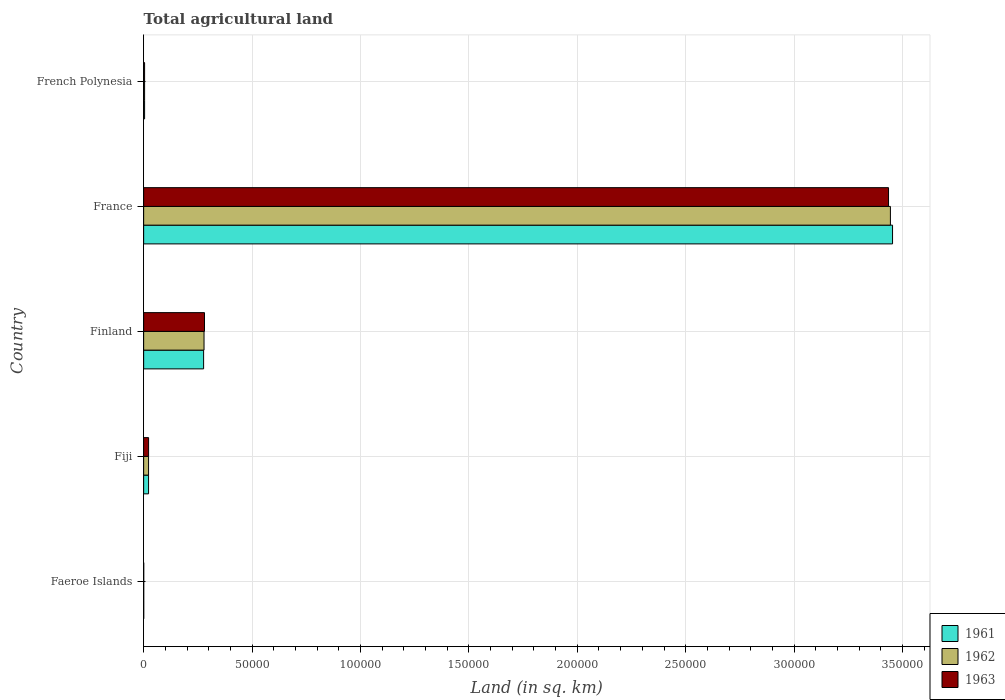How many different coloured bars are there?
Give a very brief answer. 3. Are the number of bars per tick equal to the number of legend labels?
Keep it short and to the point. Yes. Are the number of bars on each tick of the Y-axis equal?
Provide a succinct answer. Yes. How many bars are there on the 3rd tick from the bottom?
Offer a very short reply. 3. What is the label of the 3rd group of bars from the top?
Your answer should be compact. Finland. In how many cases, is the number of bars for a given country not equal to the number of legend labels?
Your response must be concise. 0. What is the total agricultural land in 1961 in French Polynesia?
Your answer should be very brief. 440. Across all countries, what is the maximum total agricultural land in 1963?
Your response must be concise. 3.44e+05. Across all countries, what is the minimum total agricultural land in 1962?
Ensure brevity in your answer.  30. In which country was the total agricultural land in 1962 maximum?
Provide a short and direct response. France. In which country was the total agricultural land in 1961 minimum?
Ensure brevity in your answer.  Faeroe Islands. What is the total total agricultural land in 1962 in the graph?
Keep it short and to the point. 3.75e+05. What is the difference between the total agricultural land in 1963 in Fiji and that in France?
Ensure brevity in your answer.  -3.41e+05. What is the difference between the total agricultural land in 1963 in French Polynesia and the total agricultural land in 1962 in France?
Your answer should be compact. -3.44e+05. What is the average total agricultural land in 1961 per country?
Ensure brevity in your answer.  7.52e+04. In how many countries, is the total agricultural land in 1963 greater than 220000 sq.km?
Give a very brief answer. 1. What is the ratio of the total agricultural land in 1962 in Faeroe Islands to that in France?
Ensure brevity in your answer.  8.710801393728223e-5. Is the difference between the total agricultural land in 1961 in France and French Polynesia greater than the difference between the total agricultural land in 1962 in France and French Polynesia?
Give a very brief answer. Yes. What is the difference between the highest and the second highest total agricultural land in 1963?
Your response must be concise. 3.15e+05. What is the difference between the highest and the lowest total agricultural land in 1962?
Offer a very short reply. 3.44e+05. In how many countries, is the total agricultural land in 1961 greater than the average total agricultural land in 1961 taken over all countries?
Provide a succinct answer. 1. What does the 2nd bar from the top in French Polynesia represents?
Provide a short and direct response. 1962. Is it the case that in every country, the sum of the total agricultural land in 1963 and total agricultural land in 1962 is greater than the total agricultural land in 1961?
Your response must be concise. Yes. How many bars are there?
Make the answer very short. 15. Are all the bars in the graph horizontal?
Your answer should be very brief. Yes. How many countries are there in the graph?
Make the answer very short. 5. What is the difference between two consecutive major ticks on the X-axis?
Your response must be concise. 5.00e+04. Does the graph contain any zero values?
Your answer should be very brief. No. Does the graph contain grids?
Make the answer very short. Yes. Where does the legend appear in the graph?
Offer a terse response. Bottom right. What is the title of the graph?
Offer a terse response. Total agricultural land. Does "1969" appear as one of the legend labels in the graph?
Your answer should be very brief. No. What is the label or title of the X-axis?
Offer a terse response. Land (in sq. km). What is the Land (in sq. km) of 1961 in Faeroe Islands?
Keep it short and to the point. 30. What is the Land (in sq. km) in 1962 in Faeroe Islands?
Your response must be concise. 30. What is the Land (in sq. km) of 1961 in Fiji?
Offer a terse response. 2270. What is the Land (in sq. km) of 1962 in Fiji?
Offer a terse response. 2270. What is the Land (in sq. km) in 1963 in Fiji?
Offer a terse response. 2280. What is the Land (in sq. km) of 1961 in Finland?
Keep it short and to the point. 2.77e+04. What is the Land (in sq. km) in 1962 in Finland?
Make the answer very short. 2.79e+04. What is the Land (in sq. km) in 1963 in Finland?
Your answer should be very brief. 2.81e+04. What is the Land (in sq. km) in 1961 in France?
Provide a short and direct response. 3.45e+05. What is the Land (in sq. km) of 1962 in France?
Give a very brief answer. 3.44e+05. What is the Land (in sq. km) of 1963 in France?
Provide a short and direct response. 3.44e+05. What is the Land (in sq. km) in 1961 in French Polynesia?
Provide a short and direct response. 440. What is the Land (in sq. km) in 1962 in French Polynesia?
Offer a terse response. 440. What is the Land (in sq. km) of 1963 in French Polynesia?
Provide a succinct answer. 440. Across all countries, what is the maximum Land (in sq. km) in 1961?
Give a very brief answer. 3.45e+05. Across all countries, what is the maximum Land (in sq. km) of 1962?
Offer a terse response. 3.44e+05. Across all countries, what is the maximum Land (in sq. km) in 1963?
Your answer should be compact. 3.44e+05. Across all countries, what is the minimum Land (in sq. km) of 1961?
Offer a terse response. 30. Across all countries, what is the minimum Land (in sq. km) of 1962?
Provide a succinct answer. 30. Across all countries, what is the minimum Land (in sq. km) of 1963?
Your answer should be compact. 30. What is the total Land (in sq. km) of 1961 in the graph?
Keep it short and to the point. 3.76e+05. What is the total Land (in sq. km) of 1962 in the graph?
Offer a terse response. 3.75e+05. What is the total Land (in sq. km) of 1963 in the graph?
Make the answer very short. 3.74e+05. What is the difference between the Land (in sq. km) of 1961 in Faeroe Islands and that in Fiji?
Your answer should be compact. -2240. What is the difference between the Land (in sq. km) in 1962 in Faeroe Islands and that in Fiji?
Your answer should be compact. -2240. What is the difference between the Land (in sq. km) of 1963 in Faeroe Islands and that in Fiji?
Give a very brief answer. -2250. What is the difference between the Land (in sq. km) in 1961 in Faeroe Islands and that in Finland?
Your response must be concise. -2.76e+04. What is the difference between the Land (in sq. km) of 1962 in Faeroe Islands and that in Finland?
Your response must be concise. -2.78e+04. What is the difference between the Land (in sq. km) in 1963 in Faeroe Islands and that in Finland?
Give a very brief answer. -2.80e+04. What is the difference between the Land (in sq. km) of 1961 in Faeroe Islands and that in France?
Your response must be concise. -3.45e+05. What is the difference between the Land (in sq. km) of 1962 in Faeroe Islands and that in France?
Keep it short and to the point. -3.44e+05. What is the difference between the Land (in sq. km) in 1963 in Faeroe Islands and that in France?
Your answer should be very brief. -3.44e+05. What is the difference between the Land (in sq. km) of 1961 in Faeroe Islands and that in French Polynesia?
Make the answer very short. -410. What is the difference between the Land (in sq. km) of 1962 in Faeroe Islands and that in French Polynesia?
Ensure brevity in your answer.  -410. What is the difference between the Land (in sq. km) of 1963 in Faeroe Islands and that in French Polynesia?
Your response must be concise. -410. What is the difference between the Land (in sq. km) of 1961 in Fiji and that in Finland?
Keep it short and to the point. -2.54e+04. What is the difference between the Land (in sq. km) of 1962 in Fiji and that in Finland?
Offer a very short reply. -2.56e+04. What is the difference between the Land (in sq. km) in 1963 in Fiji and that in Finland?
Provide a succinct answer. -2.58e+04. What is the difference between the Land (in sq. km) in 1961 in Fiji and that in France?
Provide a short and direct response. -3.43e+05. What is the difference between the Land (in sq. km) in 1962 in Fiji and that in France?
Your response must be concise. -3.42e+05. What is the difference between the Land (in sq. km) of 1963 in Fiji and that in France?
Offer a very short reply. -3.41e+05. What is the difference between the Land (in sq. km) in 1961 in Fiji and that in French Polynesia?
Make the answer very short. 1830. What is the difference between the Land (in sq. km) in 1962 in Fiji and that in French Polynesia?
Your answer should be compact. 1830. What is the difference between the Land (in sq. km) in 1963 in Fiji and that in French Polynesia?
Provide a short and direct response. 1840. What is the difference between the Land (in sq. km) in 1961 in Finland and that in France?
Offer a very short reply. -3.18e+05. What is the difference between the Land (in sq. km) of 1962 in Finland and that in France?
Offer a very short reply. -3.17e+05. What is the difference between the Land (in sq. km) of 1963 in Finland and that in France?
Your answer should be compact. -3.15e+05. What is the difference between the Land (in sq. km) of 1961 in Finland and that in French Polynesia?
Offer a terse response. 2.72e+04. What is the difference between the Land (in sq. km) of 1962 in Finland and that in French Polynesia?
Your answer should be compact. 2.74e+04. What is the difference between the Land (in sq. km) in 1963 in Finland and that in French Polynesia?
Provide a succinct answer. 2.76e+04. What is the difference between the Land (in sq. km) in 1961 in France and that in French Polynesia?
Make the answer very short. 3.45e+05. What is the difference between the Land (in sq. km) in 1962 in France and that in French Polynesia?
Your answer should be very brief. 3.44e+05. What is the difference between the Land (in sq. km) in 1963 in France and that in French Polynesia?
Offer a terse response. 3.43e+05. What is the difference between the Land (in sq. km) of 1961 in Faeroe Islands and the Land (in sq. km) of 1962 in Fiji?
Your answer should be compact. -2240. What is the difference between the Land (in sq. km) of 1961 in Faeroe Islands and the Land (in sq. km) of 1963 in Fiji?
Ensure brevity in your answer.  -2250. What is the difference between the Land (in sq. km) in 1962 in Faeroe Islands and the Land (in sq. km) in 1963 in Fiji?
Give a very brief answer. -2250. What is the difference between the Land (in sq. km) in 1961 in Faeroe Islands and the Land (in sq. km) in 1962 in Finland?
Provide a short and direct response. -2.78e+04. What is the difference between the Land (in sq. km) in 1961 in Faeroe Islands and the Land (in sq. km) in 1963 in Finland?
Make the answer very short. -2.80e+04. What is the difference between the Land (in sq. km) of 1962 in Faeroe Islands and the Land (in sq. km) of 1963 in Finland?
Your answer should be compact. -2.80e+04. What is the difference between the Land (in sq. km) in 1961 in Faeroe Islands and the Land (in sq. km) in 1962 in France?
Offer a very short reply. -3.44e+05. What is the difference between the Land (in sq. km) in 1961 in Faeroe Islands and the Land (in sq. km) in 1963 in France?
Provide a short and direct response. -3.44e+05. What is the difference between the Land (in sq. km) in 1962 in Faeroe Islands and the Land (in sq. km) in 1963 in France?
Your answer should be compact. -3.44e+05. What is the difference between the Land (in sq. km) of 1961 in Faeroe Islands and the Land (in sq. km) of 1962 in French Polynesia?
Provide a short and direct response. -410. What is the difference between the Land (in sq. km) in 1961 in Faeroe Islands and the Land (in sq. km) in 1963 in French Polynesia?
Offer a very short reply. -410. What is the difference between the Land (in sq. km) in 1962 in Faeroe Islands and the Land (in sq. km) in 1963 in French Polynesia?
Provide a succinct answer. -410. What is the difference between the Land (in sq. km) in 1961 in Fiji and the Land (in sq. km) in 1962 in Finland?
Keep it short and to the point. -2.56e+04. What is the difference between the Land (in sq. km) in 1961 in Fiji and the Land (in sq. km) in 1963 in Finland?
Keep it short and to the point. -2.58e+04. What is the difference between the Land (in sq. km) in 1962 in Fiji and the Land (in sq. km) in 1963 in Finland?
Ensure brevity in your answer.  -2.58e+04. What is the difference between the Land (in sq. km) in 1961 in Fiji and the Land (in sq. km) in 1962 in France?
Offer a very short reply. -3.42e+05. What is the difference between the Land (in sq. km) of 1961 in Fiji and the Land (in sq. km) of 1963 in France?
Your answer should be compact. -3.41e+05. What is the difference between the Land (in sq. km) in 1962 in Fiji and the Land (in sq. km) in 1963 in France?
Your answer should be very brief. -3.41e+05. What is the difference between the Land (in sq. km) of 1961 in Fiji and the Land (in sq. km) of 1962 in French Polynesia?
Your answer should be very brief. 1830. What is the difference between the Land (in sq. km) in 1961 in Fiji and the Land (in sq. km) in 1963 in French Polynesia?
Your answer should be very brief. 1830. What is the difference between the Land (in sq. km) of 1962 in Fiji and the Land (in sq. km) of 1963 in French Polynesia?
Your answer should be compact. 1830. What is the difference between the Land (in sq. km) of 1961 in Finland and the Land (in sq. km) of 1962 in France?
Make the answer very short. -3.17e+05. What is the difference between the Land (in sq. km) of 1961 in Finland and the Land (in sq. km) of 1963 in France?
Ensure brevity in your answer.  -3.16e+05. What is the difference between the Land (in sq. km) of 1962 in Finland and the Land (in sq. km) of 1963 in France?
Ensure brevity in your answer.  -3.16e+05. What is the difference between the Land (in sq. km) in 1961 in Finland and the Land (in sq. km) in 1962 in French Polynesia?
Provide a succinct answer. 2.72e+04. What is the difference between the Land (in sq. km) in 1961 in Finland and the Land (in sq. km) in 1963 in French Polynesia?
Keep it short and to the point. 2.72e+04. What is the difference between the Land (in sq. km) of 1962 in Finland and the Land (in sq. km) of 1963 in French Polynesia?
Give a very brief answer. 2.74e+04. What is the difference between the Land (in sq. km) in 1961 in France and the Land (in sq. km) in 1962 in French Polynesia?
Your answer should be very brief. 3.45e+05. What is the difference between the Land (in sq. km) of 1961 in France and the Land (in sq. km) of 1963 in French Polynesia?
Provide a short and direct response. 3.45e+05. What is the difference between the Land (in sq. km) in 1962 in France and the Land (in sq. km) in 1963 in French Polynesia?
Ensure brevity in your answer.  3.44e+05. What is the average Land (in sq. km) of 1961 per country?
Offer a very short reply. 7.52e+04. What is the average Land (in sq. km) in 1962 per country?
Keep it short and to the point. 7.50e+04. What is the average Land (in sq. km) in 1963 per country?
Offer a very short reply. 7.49e+04. What is the difference between the Land (in sq. km) of 1961 and Land (in sq. km) of 1962 in Fiji?
Offer a terse response. 0. What is the difference between the Land (in sq. km) of 1961 and Land (in sq. km) of 1963 in Fiji?
Give a very brief answer. -10. What is the difference between the Land (in sq. km) of 1962 and Land (in sq. km) of 1963 in Fiji?
Ensure brevity in your answer.  -10. What is the difference between the Land (in sq. km) of 1961 and Land (in sq. km) of 1962 in Finland?
Ensure brevity in your answer.  -194. What is the difference between the Land (in sq. km) of 1961 and Land (in sq. km) of 1963 in Finland?
Offer a very short reply. -408. What is the difference between the Land (in sq. km) in 1962 and Land (in sq. km) in 1963 in Finland?
Offer a terse response. -214. What is the difference between the Land (in sq. km) in 1961 and Land (in sq. km) in 1962 in France?
Provide a short and direct response. 990. What is the difference between the Land (in sq. km) of 1961 and Land (in sq. km) of 1963 in France?
Make the answer very short. 1850. What is the difference between the Land (in sq. km) of 1962 and Land (in sq. km) of 1963 in France?
Keep it short and to the point. 860. What is the difference between the Land (in sq. km) in 1962 and Land (in sq. km) in 1963 in French Polynesia?
Offer a very short reply. 0. What is the ratio of the Land (in sq. km) in 1961 in Faeroe Islands to that in Fiji?
Offer a terse response. 0.01. What is the ratio of the Land (in sq. km) in 1962 in Faeroe Islands to that in Fiji?
Give a very brief answer. 0.01. What is the ratio of the Land (in sq. km) of 1963 in Faeroe Islands to that in Fiji?
Make the answer very short. 0.01. What is the ratio of the Land (in sq. km) of 1961 in Faeroe Islands to that in Finland?
Make the answer very short. 0. What is the ratio of the Land (in sq. km) of 1962 in Faeroe Islands to that in Finland?
Your response must be concise. 0. What is the ratio of the Land (in sq. km) of 1963 in Faeroe Islands to that in Finland?
Provide a short and direct response. 0. What is the ratio of the Land (in sq. km) in 1961 in Faeroe Islands to that in France?
Provide a short and direct response. 0. What is the ratio of the Land (in sq. km) in 1962 in Faeroe Islands to that in France?
Provide a succinct answer. 0. What is the ratio of the Land (in sq. km) of 1963 in Faeroe Islands to that in France?
Keep it short and to the point. 0. What is the ratio of the Land (in sq. km) in 1961 in Faeroe Islands to that in French Polynesia?
Provide a short and direct response. 0.07. What is the ratio of the Land (in sq. km) in 1962 in Faeroe Islands to that in French Polynesia?
Give a very brief answer. 0.07. What is the ratio of the Land (in sq. km) in 1963 in Faeroe Islands to that in French Polynesia?
Provide a succinct answer. 0.07. What is the ratio of the Land (in sq. km) of 1961 in Fiji to that in Finland?
Make the answer very short. 0.08. What is the ratio of the Land (in sq. km) in 1962 in Fiji to that in Finland?
Ensure brevity in your answer.  0.08. What is the ratio of the Land (in sq. km) of 1963 in Fiji to that in Finland?
Your answer should be very brief. 0.08. What is the ratio of the Land (in sq. km) of 1961 in Fiji to that in France?
Your answer should be compact. 0.01. What is the ratio of the Land (in sq. km) of 1962 in Fiji to that in France?
Offer a terse response. 0.01. What is the ratio of the Land (in sq. km) in 1963 in Fiji to that in France?
Provide a short and direct response. 0.01. What is the ratio of the Land (in sq. km) of 1961 in Fiji to that in French Polynesia?
Give a very brief answer. 5.16. What is the ratio of the Land (in sq. km) in 1962 in Fiji to that in French Polynesia?
Provide a short and direct response. 5.16. What is the ratio of the Land (in sq. km) in 1963 in Fiji to that in French Polynesia?
Make the answer very short. 5.18. What is the ratio of the Land (in sq. km) of 1961 in Finland to that in France?
Your answer should be very brief. 0.08. What is the ratio of the Land (in sq. km) in 1962 in Finland to that in France?
Give a very brief answer. 0.08. What is the ratio of the Land (in sq. km) in 1963 in Finland to that in France?
Give a very brief answer. 0.08. What is the ratio of the Land (in sq. km) of 1961 in Finland to that in French Polynesia?
Provide a succinct answer. 62.86. What is the ratio of the Land (in sq. km) of 1962 in Finland to that in French Polynesia?
Provide a short and direct response. 63.3. What is the ratio of the Land (in sq. km) of 1963 in Finland to that in French Polynesia?
Your response must be concise. 63.78. What is the ratio of the Land (in sq. km) in 1961 in France to that in French Polynesia?
Keep it short and to the point. 784.98. What is the ratio of the Land (in sq. km) of 1962 in France to that in French Polynesia?
Provide a short and direct response. 782.73. What is the ratio of the Land (in sq. km) of 1963 in France to that in French Polynesia?
Provide a succinct answer. 780.77. What is the difference between the highest and the second highest Land (in sq. km) in 1961?
Provide a succinct answer. 3.18e+05. What is the difference between the highest and the second highest Land (in sq. km) in 1962?
Provide a succinct answer. 3.17e+05. What is the difference between the highest and the second highest Land (in sq. km) in 1963?
Provide a succinct answer. 3.15e+05. What is the difference between the highest and the lowest Land (in sq. km) of 1961?
Your answer should be very brief. 3.45e+05. What is the difference between the highest and the lowest Land (in sq. km) in 1962?
Ensure brevity in your answer.  3.44e+05. What is the difference between the highest and the lowest Land (in sq. km) in 1963?
Give a very brief answer. 3.44e+05. 